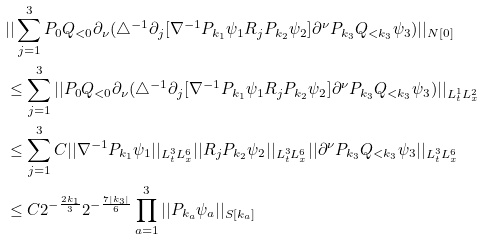<formula> <loc_0><loc_0><loc_500><loc_500>& | | \sum _ { j = 1 } ^ { 3 } P _ { 0 } Q _ { < 0 } \partial _ { \nu } ( \triangle ^ { - 1 } \partial _ { j } [ \nabla ^ { - 1 } P _ { k _ { 1 } } \psi _ { 1 } R _ { j } P _ { k _ { 2 } } \psi _ { 2 } ] \partial ^ { \nu } P _ { k _ { 3 } } Q _ { < k _ { 3 } } \psi _ { 3 } ) | | _ { N [ 0 ] } \\ & \leq \sum _ { j = 1 } ^ { 3 } | | P _ { 0 } Q _ { < 0 } \partial _ { \nu } ( \triangle ^ { - 1 } \partial _ { j } [ \nabla ^ { - 1 } P _ { k _ { 1 } } \psi _ { 1 } R _ { j } P _ { k _ { 2 } } \psi _ { 2 } ] \partial ^ { \nu } P _ { k _ { 3 } } Q _ { < k _ { 3 } } \psi _ { 3 } ) | | _ { L _ { t } ^ { 1 } L _ { x } ^ { 2 } } \\ & \leq \sum _ { j = 1 } ^ { 3 } C | | \nabla ^ { - 1 } P _ { k _ { 1 } } \psi _ { 1 } | | _ { L _ { t } ^ { 3 } L _ { x } ^ { 6 } } | | R _ { j } P _ { k _ { 2 } } \psi _ { 2 } | | _ { L _ { t } ^ { 3 } L _ { x } ^ { 6 } } | | \partial ^ { \nu } P _ { k _ { 3 } } Q _ { < k _ { 3 } } \psi _ { 3 } | | _ { L _ { t } ^ { 3 } L _ { x } ^ { 6 } } \\ & \leq C 2 ^ { - \frac { 2 k _ { 1 } } { 3 } } 2 ^ { - \frac { 7 | k _ { 3 } | } { 6 } } \prod _ { a = 1 } ^ { 3 } | | P _ { k _ { a } } \psi _ { a } | | _ { S [ k _ { a } ] } \\</formula> 